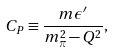Convert formula to latex. <formula><loc_0><loc_0><loc_500><loc_500>C _ { P } \equiv \frac { m \epsilon ^ { \prime } } { m _ { \pi } ^ { 2 } - Q ^ { 2 } } ,</formula> 